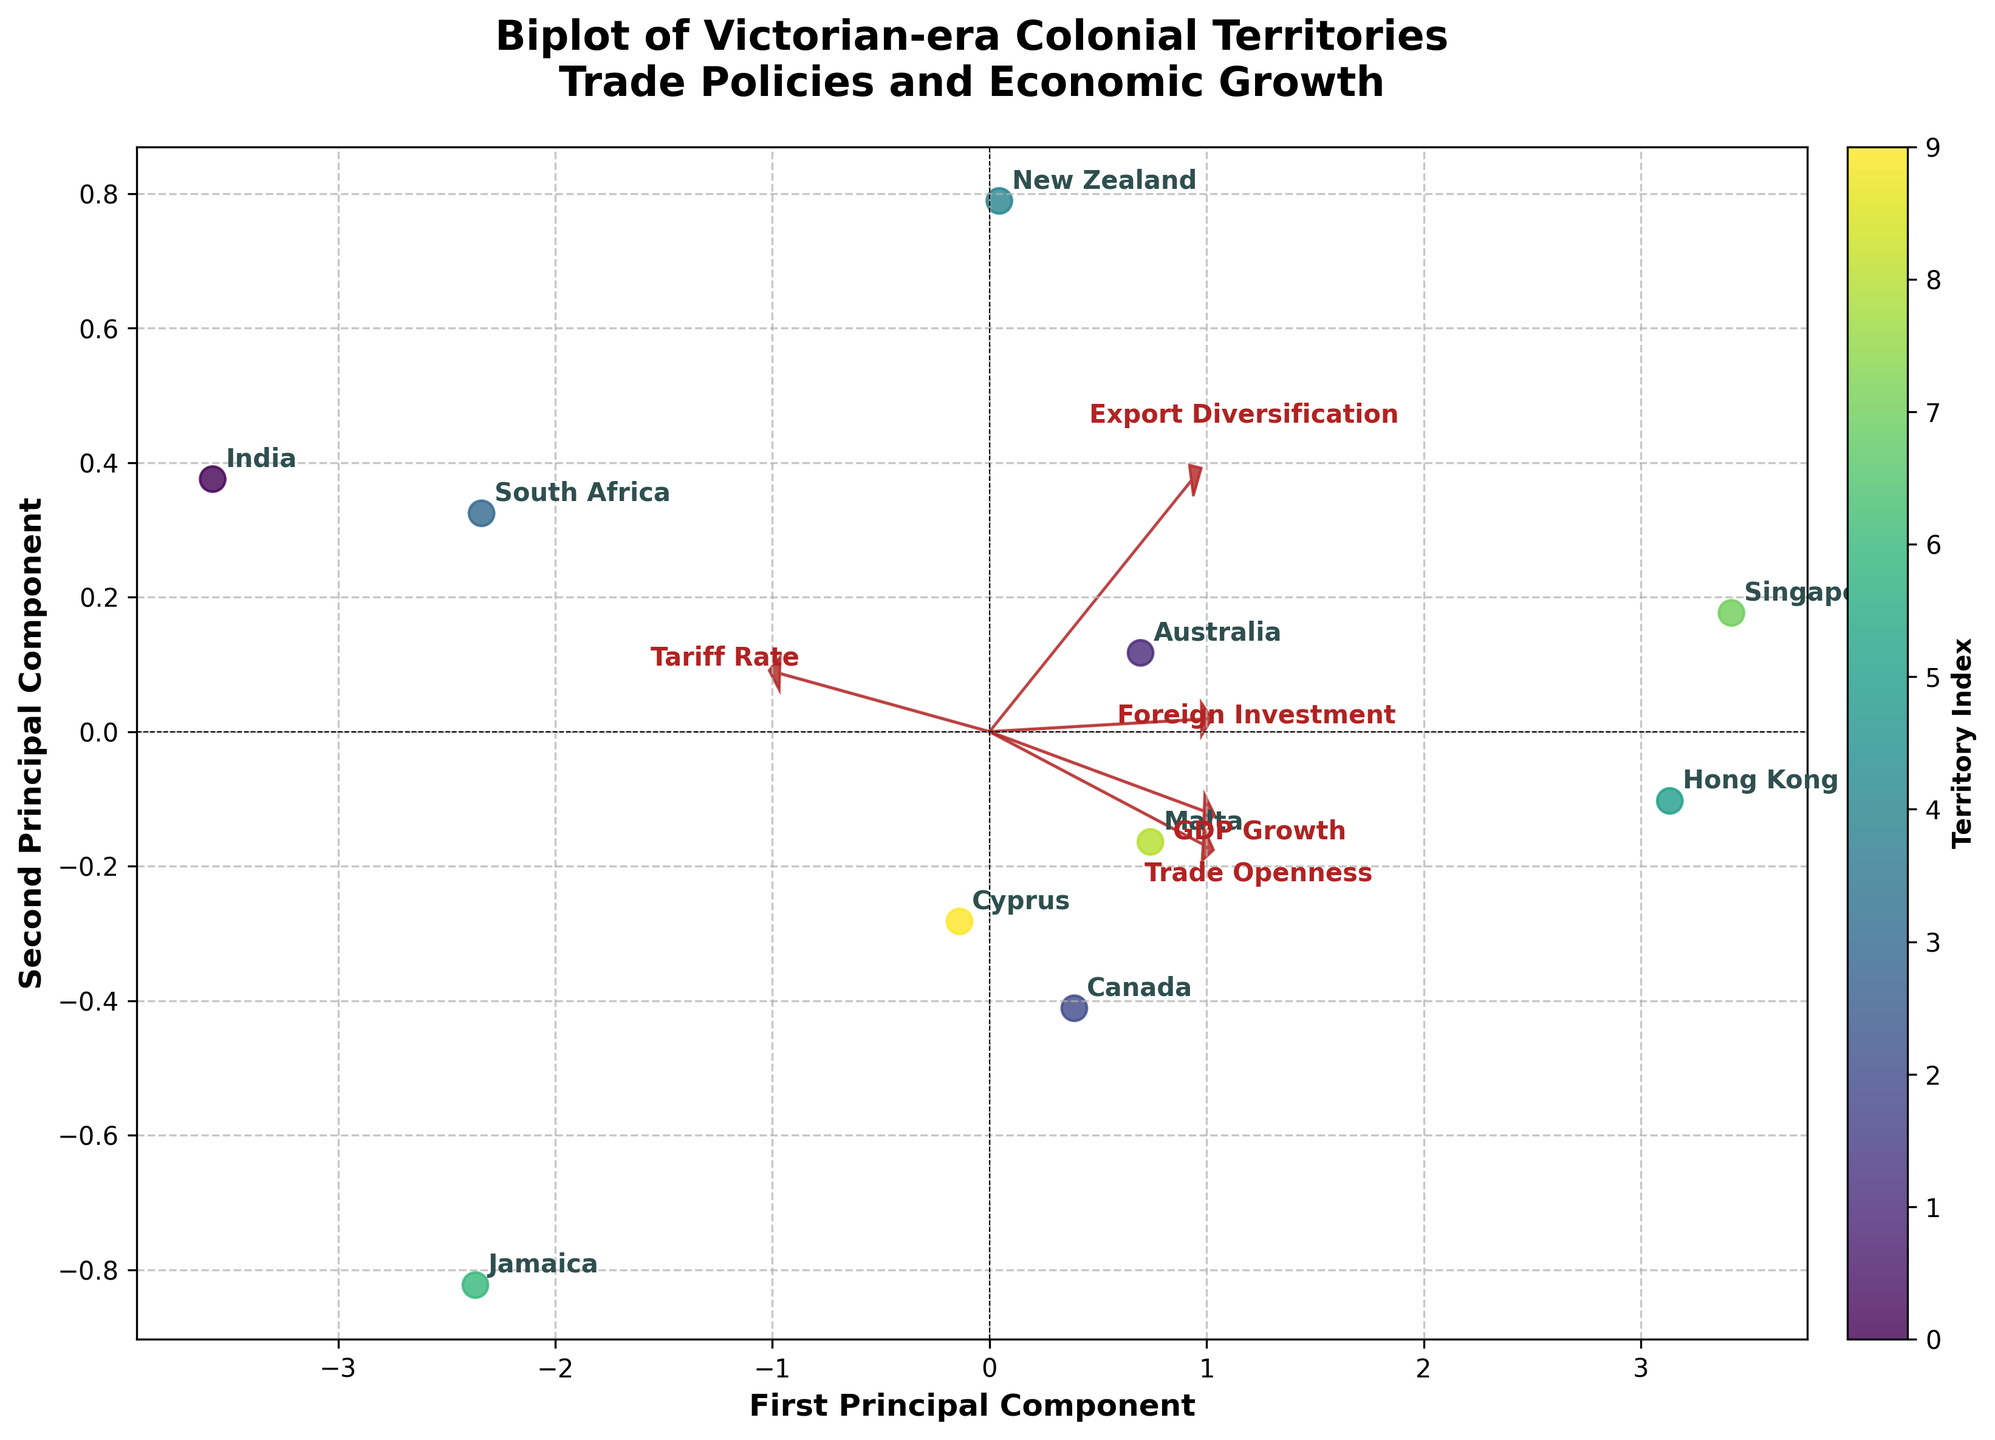What is the title of the biplot? The title of the biplot can be found at the top of the figure in a larger and bold font for better visibility. It provides an overall summary of what the figure represents. Here, it clearly states the focus on Victorian-era colonial territories with an emphasis on trade policies and economic growth.
Answer: Biplot of Victorian-era Colonial Territories Trade Policies and Economic Growth How many territories are represented in the biplot? Count the number of labels corresponding to territories that are scattered across the plot. Each label signifies a different territory analyzed in the study.
Answer: 10 Which territory has the highest trade openness? Look for the loadings related to the 'Trade Openness' vector and observe the territory that lies furthest in its direction. High trade openness will align more closely with this vector.
Answer: Singapore Which territory shows the highest GDP growth? Identify where the 'GDP Growth' vector points and observe which data point (territory) is farthest along this vector direction, indicating the highest value in this measure.
Answer: Singapore What can be inferred about Hong Kong's trade policy from the biplot? Examine Hong Kong's position relative to the vectors. Since Hong Kong is closer to vectors representing high trade openness and low tariff rate, it signifies liberal trade policies. The location relative to other vectors can provide more insights.
Answer: Liberal trade policy Are Canada and Australia similar in terms of trade openness and GDP growth? Compare the positions of Canada and Australia on the plot, particularly in relation to the 'Trade Openness' and 'GDP Growth' vectors to determine if they are close to each other.
Answer: Yes Which economic feature is most strongly associated with the first principal component? Examine the direction and length of the vectors corresponding to each economic feature. The vector that aligns most strongly with the x-axis (first principal component) represents that feature.
Answer: Trade Openness Do territories with higher foreign investment tend to have diverse exports? Observe the correlation between the 'Foreign Investment' and 'Export Diversification' vectors. Territories that are positioned in the direction indicating high values for one should also align similarly with the other for a positive correlation.
Answer: Yes How does Jamaica's economic profile differ from Hong Kong's? Compare the positions of Jamaica and Hong Kong in the biplot, considering their proximity to vectors representing different economic features like 'Trade Openness,' 'GDP Growth,' and 'Tariff Rate.'
Answer: Jamaica has higher tariff rates and lower trade openness compared to Hong Kong Which territories appear to have a trade policy focused on low tariff rates? Look at territories near the 'Tariff Rate' vector's lower end, indicating minimal tariffs. The closer a territory is to this end, the lower its tariff rates.
Answer: Hong Kong, Singapore 